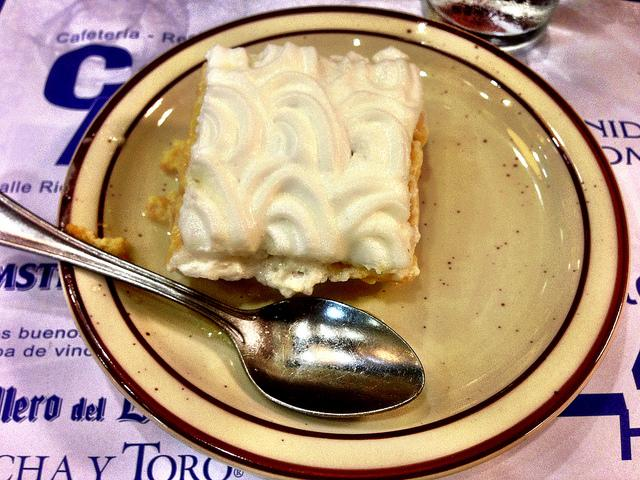What is on the plate? Please explain your reasoning. spoon. A utensil is on the plate. 